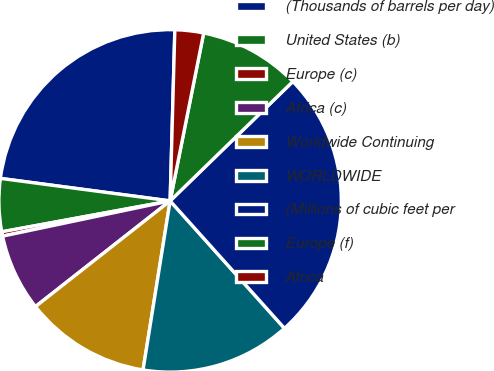<chart> <loc_0><loc_0><loc_500><loc_500><pie_chart><fcel>(Thousands of barrels per day)<fcel>United States (b)<fcel>Europe (c)<fcel>Africa (c)<fcel>Worldwide Continuing<fcel>WORLDWIDE<fcel>(Millions of cubic feet per<fcel>Europe (f)<fcel>Africa<nl><fcel>23.34%<fcel>4.99%<fcel>0.41%<fcel>7.29%<fcel>11.88%<fcel>14.17%<fcel>25.64%<fcel>9.58%<fcel>2.7%<nl></chart> 